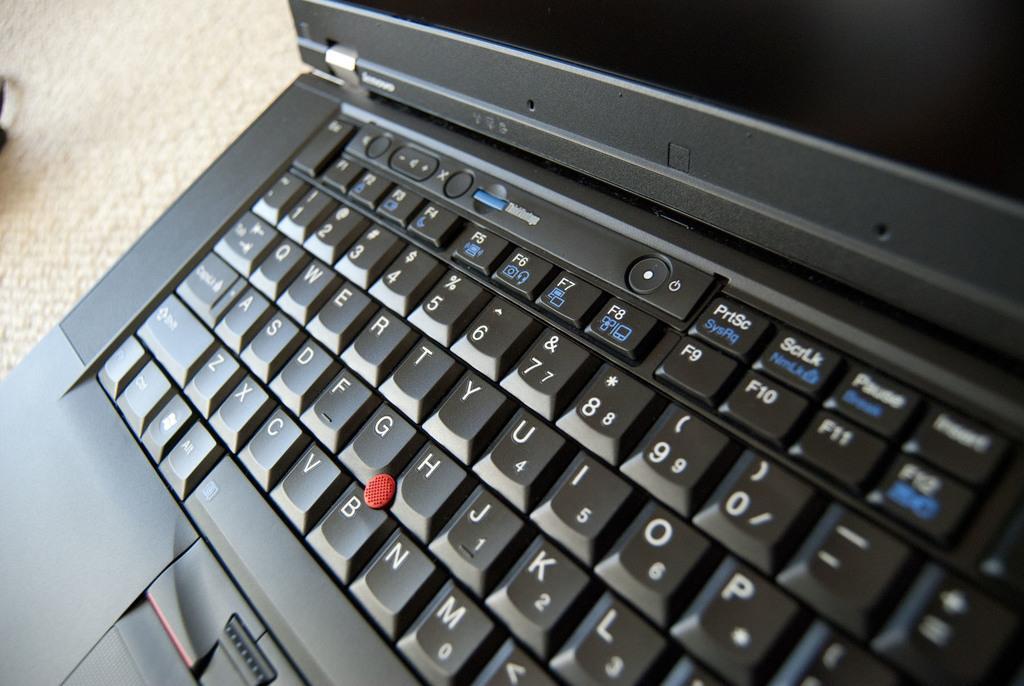Could you give a brief overview of what you see in this image? In this image I can see a black color laptop and a keypad. 